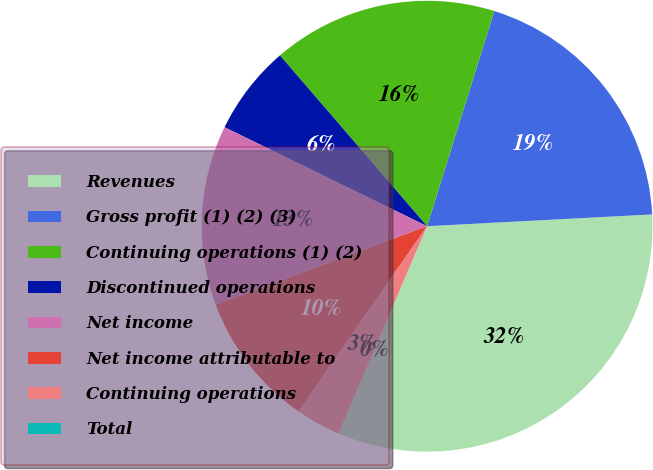Convert chart. <chart><loc_0><loc_0><loc_500><loc_500><pie_chart><fcel>Revenues<fcel>Gross profit (1) (2) (3)<fcel>Continuing operations (1) (2)<fcel>Discontinued operations<fcel>Net income<fcel>Net income attributable to<fcel>Continuing operations<fcel>Total<nl><fcel>32.26%<fcel>19.35%<fcel>16.13%<fcel>6.45%<fcel>12.9%<fcel>9.68%<fcel>3.23%<fcel>0.0%<nl></chart> 